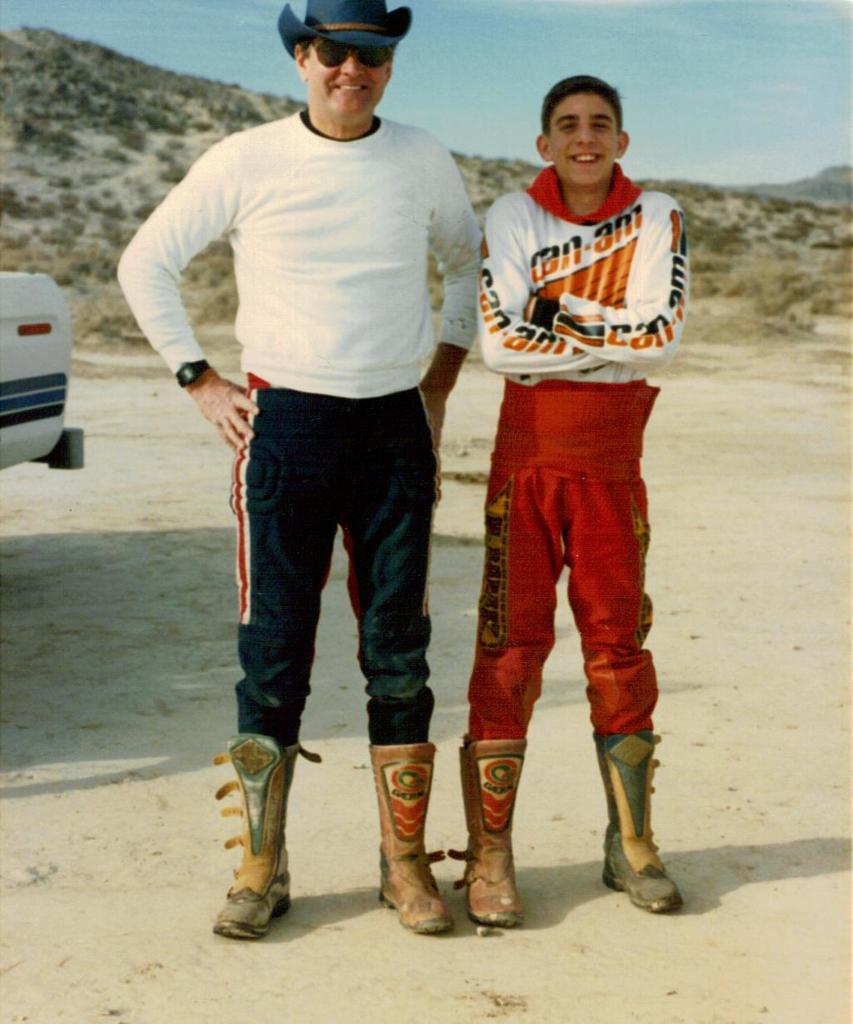<image>
Give a short and clear explanation of the subsequent image. A young man wearing a Can Am racing outfit stands next to an older man. 